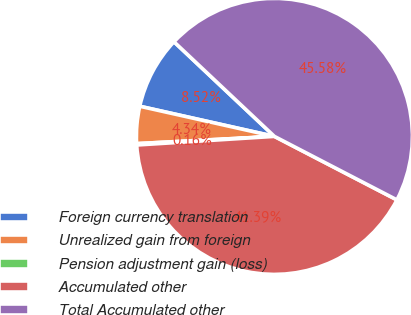Convert chart. <chart><loc_0><loc_0><loc_500><loc_500><pie_chart><fcel>Foreign currency translation<fcel>Unrealized gain from foreign<fcel>Pension adjustment gain (loss)<fcel>Accumulated other<fcel>Total Accumulated other<nl><fcel>8.52%<fcel>4.34%<fcel>0.16%<fcel>41.39%<fcel>45.58%<nl></chart> 